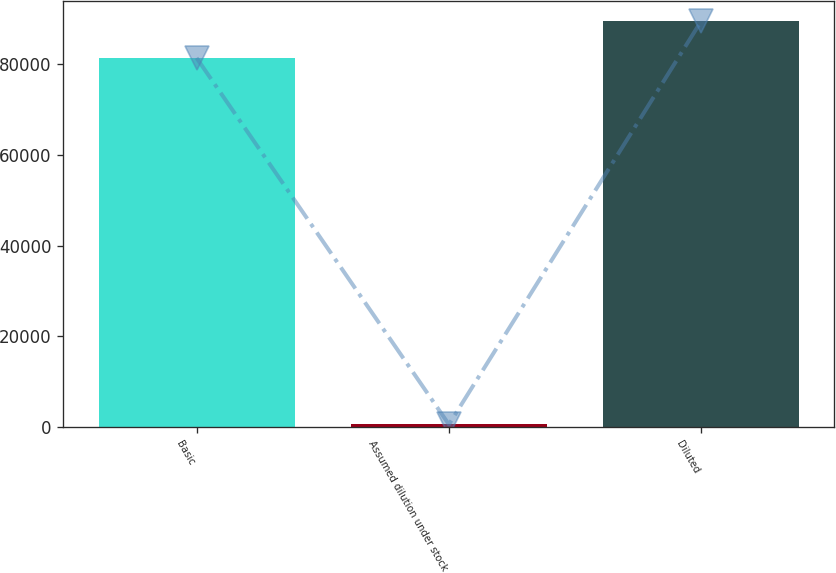Convert chart. <chart><loc_0><loc_0><loc_500><loc_500><bar_chart><fcel>Basic<fcel>Assumed dilution under stock<fcel>Diluted<nl><fcel>81322<fcel>608<fcel>89454.2<nl></chart> 